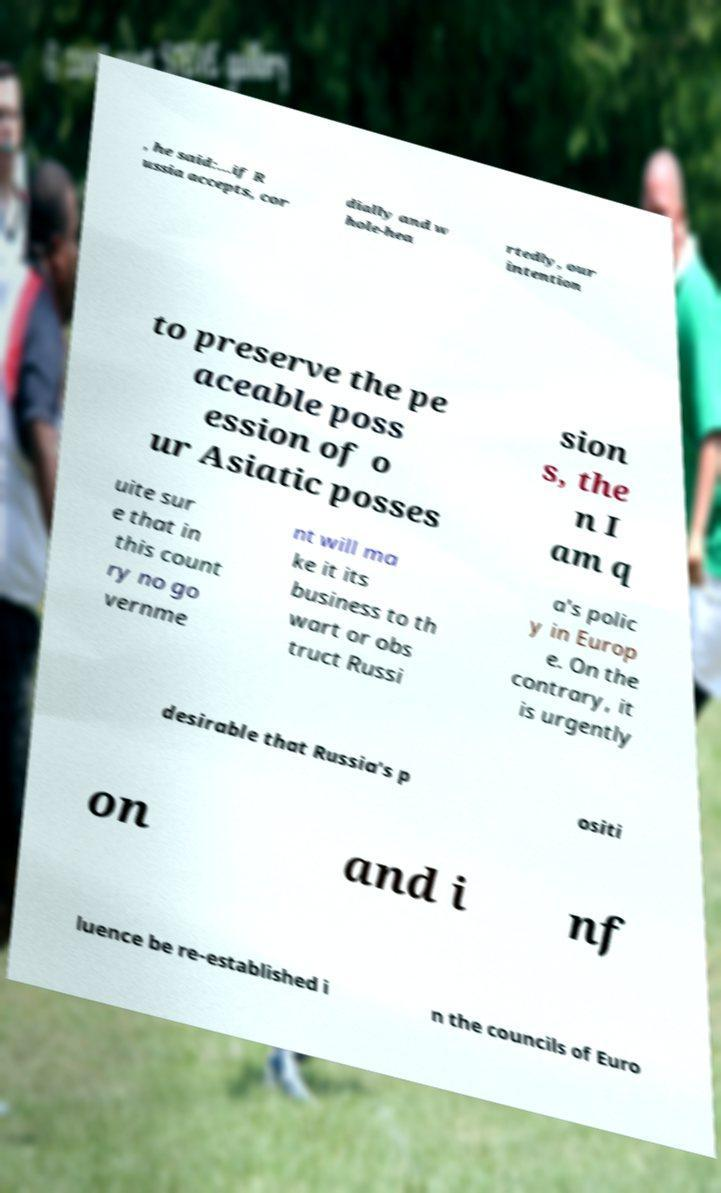Please read and relay the text visible in this image. What does it say? , he said:...if R ussia accepts, cor dially and w hole-hea rtedly, our intention to preserve the pe aceable poss ession of o ur Asiatic posses sion s, the n I am q uite sur e that in this count ry no go vernme nt will ma ke it its business to th wart or obs truct Russi a's polic y in Europ e. On the contrary, it is urgently desirable that Russia's p ositi on and i nf luence be re-established i n the councils of Euro 